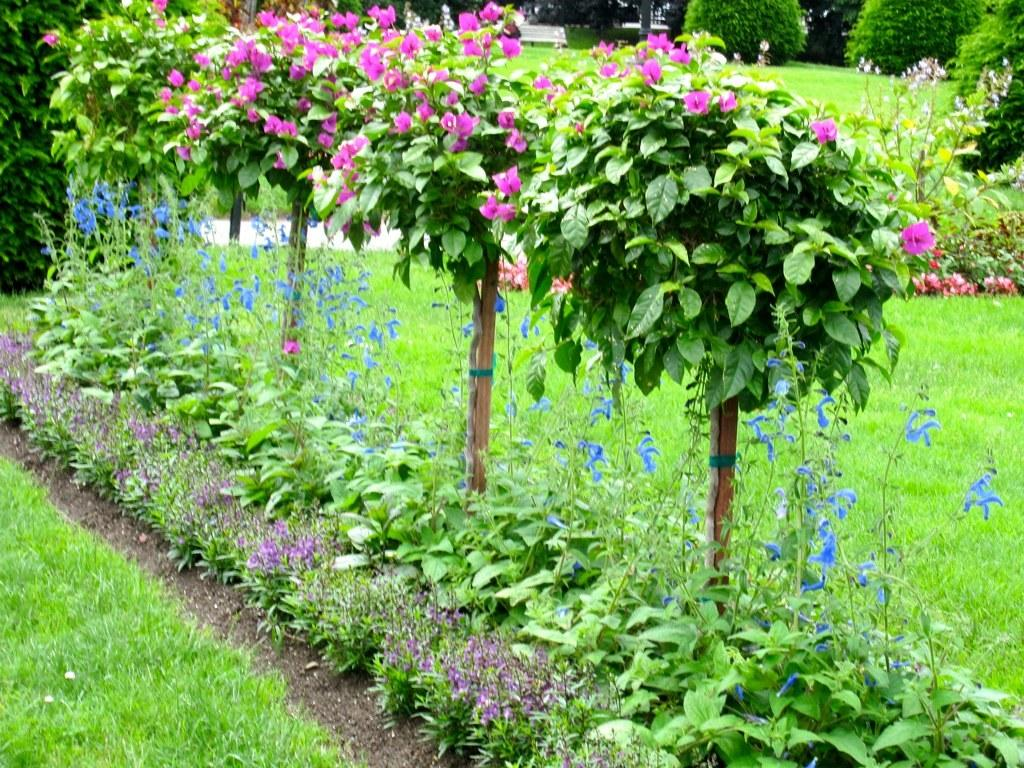What type of outdoor area is depicted in the image? There is a beautiful garden in the image. What types of plants can be seen in the garden? The garden contains flowers and small plants. What type of vegetation covers the ground in the garden? The garden contains grass. What type of trousers are the flowers wearing in the image? The flowers in the image are not wearing trousers, as they are plants and not people. What thrilling activity is taking place in the garden in the image? There is no specific thrilling activity taking place in the garden in the image; it is simply a beautiful garden with flowers, small plants, and grass. 